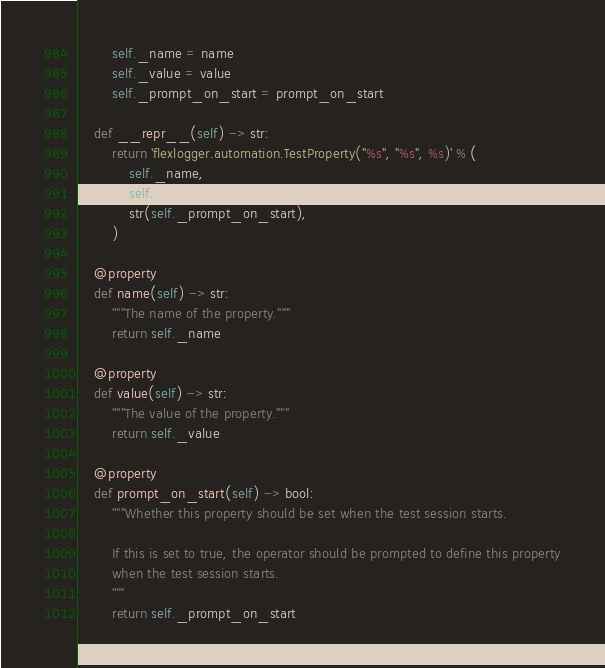<code> <loc_0><loc_0><loc_500><loc_500><_Python_>        self._name = name
        self._value = value
        self._prompt_on_start = prompt_on_start

    def __repr__(self) -> str:
        return 'flexlogger.automation.TestProperty("%s", "%s", %s)' % (
            self._name,
            self._value,
            str(self._prompt_on_start),
        )

    @property
    def name(self) -> str:
        """The name of the property."""
        return self._name

    @property
    def value(self) -> str:
        """The value of the property."""
        return self._value

    @property
    def prompt_on_start(self) -> bool:
        """Whether this property should be set when the test session starts.

        If this is set to true, the operator should be prompted to define this property
        when the test session starts.
        """
        return self._prompt_on_start
</code> 